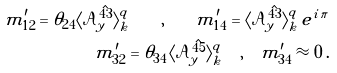Convert formula to latex. <formula><loc_0><loc_0><loc_500><loc_500>\tilde { m } ^ { \prime } _ { 1 2 } = \theta _ { 2 4 } \langle \mathcal { A } _ { y } ^ { \hat { 4 3 } } \rangle ^ { q } _ { k } \quad , \quad \tilde { m } ^ { \prime } _ { 1 4 } = \langle \mathcal { A } _ { y } ^ { \hat { 4 3 } } \rangle ^ { q } _ { k } \, e ^ { i \, \pi } \\ \tilde { m } ^ { \prime } _ { 3 2 } = \theta _ { 3 4 } \, \langle \mathcal { A } _ { y } ^ { \hat { 4 5 } } \rangle ^ { q } _ { k } \quad , \quad \tilde { m } ^ { \prime } _ { 3 4 } \approx 0 \, .</formula> 